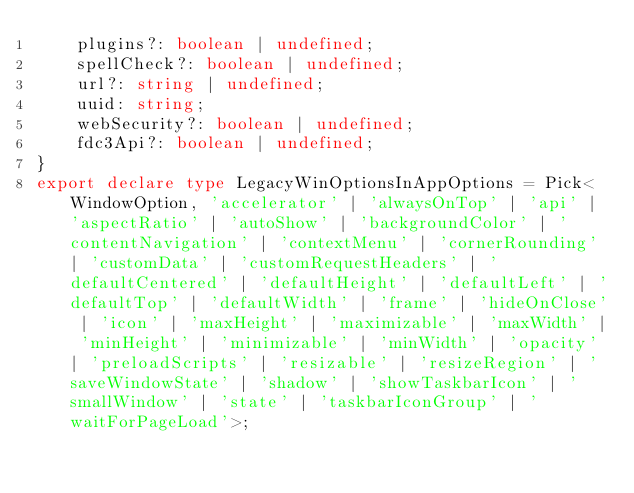Convert code to text. <code><loc_0><loc_0><loc_500><loc_500><_TypeScript_>    plugins?: boolean | undefined;
    spellCheck?: boolean | undefined;
    url?: string | undefined;
    uuid: string;
    webSecurity?: boolean | undefined;
    fdc3Api?: boolean | undefined;
}
export declare type LegacyWinOptionsInAppOptions = Pick<WindowOption, 'accelerator' | 'alwaysOnTop' | 'api' | 'aspectRatio' | 'autoShow' | 'backgroundColor' | 'contentNavigation' | 'contextMenu' | 'cornerRounding' | 'customData' | 'customRequestHeaders' | 'defaultCentered' | 'defaultHeight' | 'defaultLeft' | 'defaultTop' | 'defaultWidth' | 'frame' | 'hideOnClose' | 'icon' | 'maxHeight' | 'maximizable' | 'maxWidth' | 'minHeight' | 'minimizable' | 'minWidth' | 'opacity' | 'preloadScripts' | 'resizable' | 'resizeRegion' | 'saveWindowState' | 'shadow' | 'showTaskbarIcon' | 'smallWindow' | 'state' | 'taskbarIconGroup' | 'waitForPageLoad'>;
</code> 